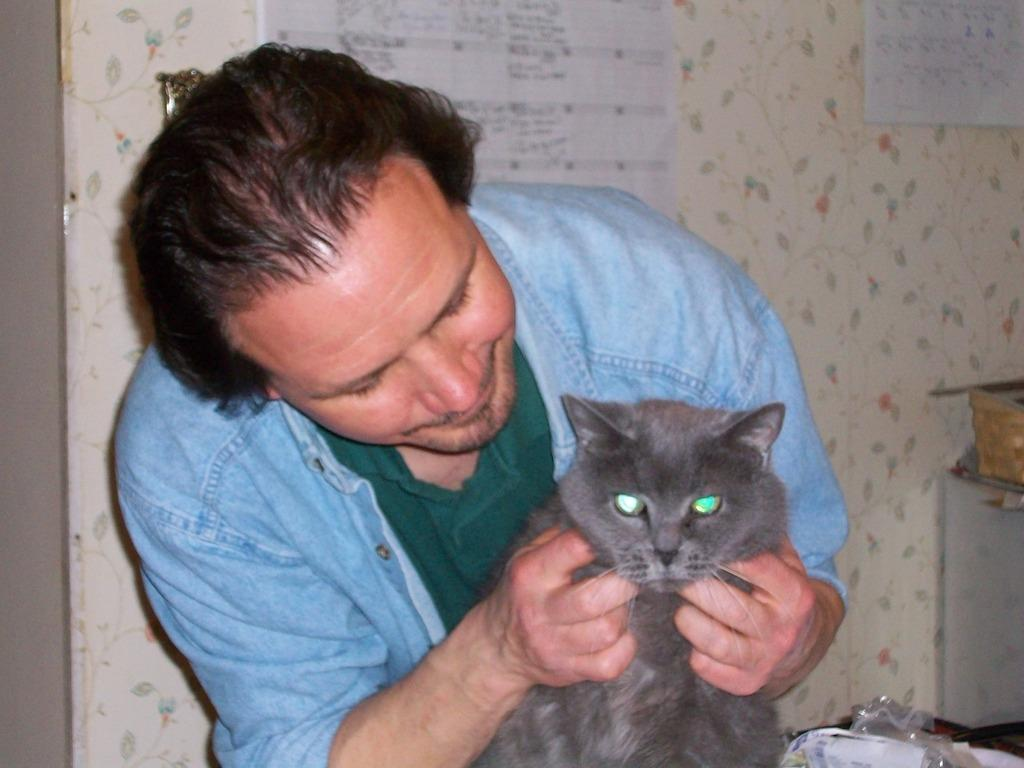Who is present in the image? There is a man in the image. What is the man holding in the image? The man is holding a cat. What type of quince is the man wearing on his head in the image? There is no quince or crown present in the image; the man is simply holding a cat. 